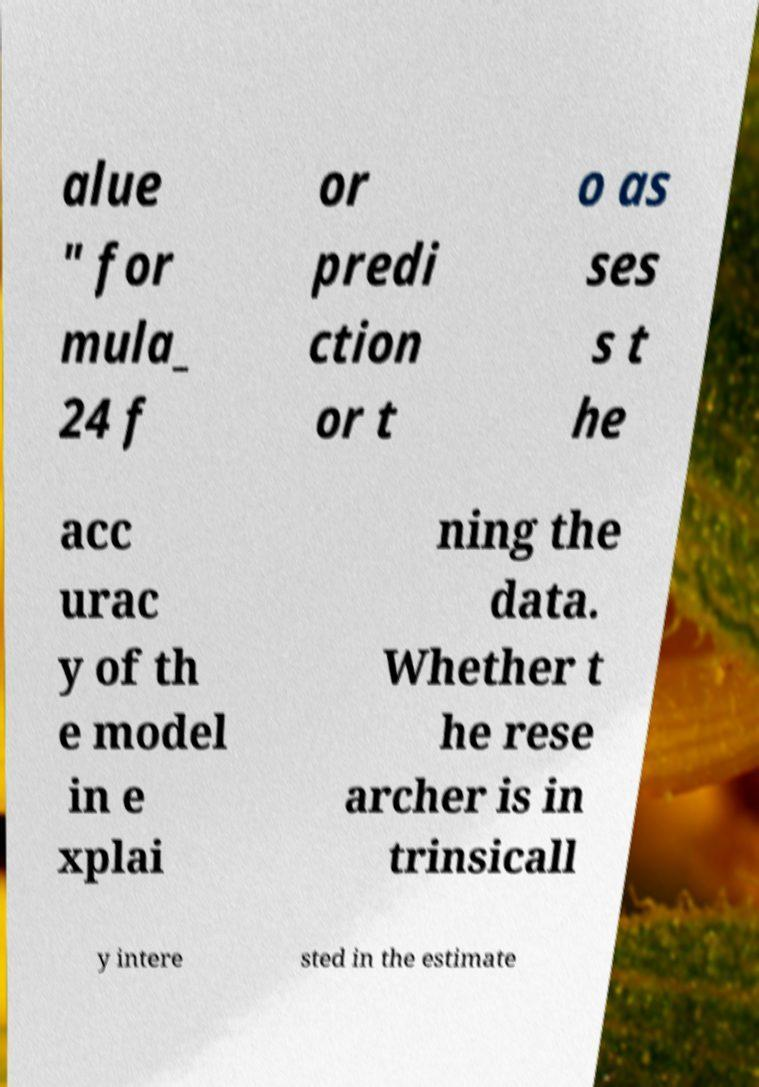Could you assist in decoding the text presented in this image and type it out clearly? alue " for mula_ 24 f or predi ction or t o as ses s t he acc urac y of th e model in e xplai ning the data. Whether t he rese archer is in trinsicall y intere sted in the estimate 